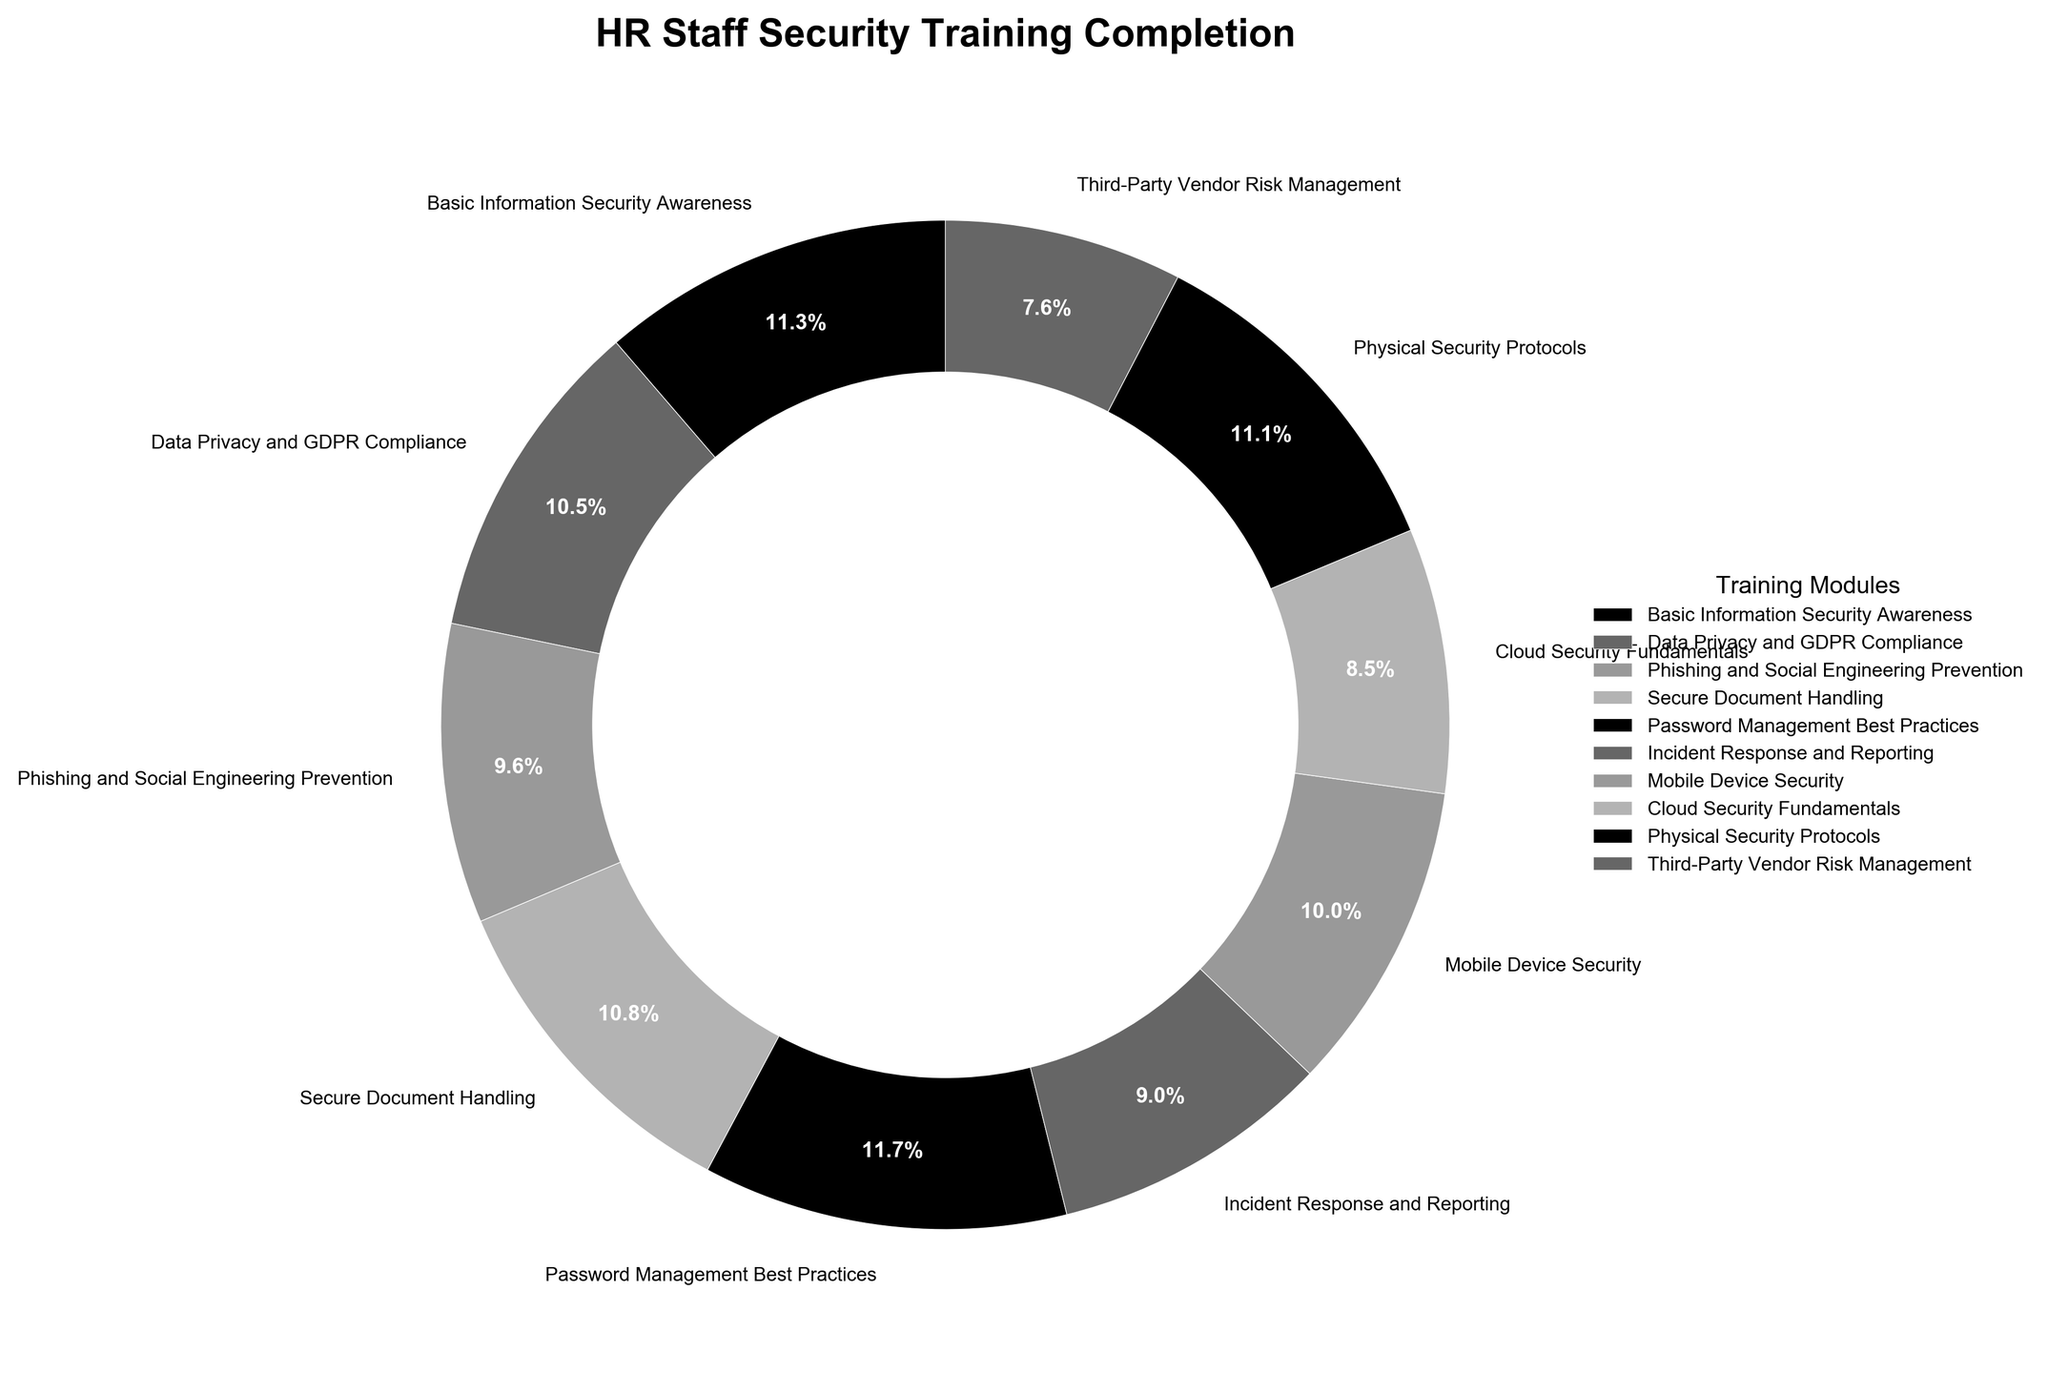What's the completion percentage for the "Cloud Security Fundamentals" training module? Locate the segment labeled "Cloud Security Fundamentals" in the pie chart and refer to the percentage shown there.
Answer: 69% Which training module has the highest completion percentage? Look for the largest segment in the pie chart, which represents the highest completion percentage.
Answer: Password Management Best Practices Compare the completion percentages of "Basic Information Security Awareness" and "Mobile Device Security". Which one is higher and by how much? Identify the segments labeled "Basic Information Security Awareness" and "Mobile Device Security" and compare their percentages (92% and 81%, respectively). Subtract the smaller percentage from the larger one (92% - 81% = 11%).
Answer: Basic Information Security Awareness by 11% What is the average completion percentage of all the training modules? Sum all the completion percentages listed in the pie chart (92, 85, 78, 88, 95, 73, 81, 69, 90, 62) and divide by the number of training modules (10). (92 + 85 + 78 + 88 + 95 + 73 + 81 + 69 + 90 + 62) / 10 = 813 / 10 = 81.3%.
Answer: 81.3% Which training module has the lowest completion percentage? Identify the smallest segment in the pie chart, which represents the lowest completion percentage.
Answer: Third-Party Vendor Risk Management What is the total completion percentage for "Data Privacy and GDPR Compliance", "Incident Response and Reporting", and "Physical Security Protocols"? Sum the completion percentages of the specified training modules (85, 73, and 90). 85 + 73 + 90 = 248.
Answer: 248% Is the completion percentage for "Phishing and Social Engineering Prevention" greater than or less than 80%? Locate the segment for "Phishing and Social Engineering Prevention" and refer to the percentage (78%). Compare it with 80%.
Answer: Less than 80% What can you conclude about the overall level of security awareness among the HR staff based on the pie chart? Observe the completion percentages for each training module. Most percentages are relatively high, indicating that the majority of HR staff have completed the required security training modules, although there are a few modules with lower completion percentages that might need further attention.
Answer: High overall, but some modules need attention 